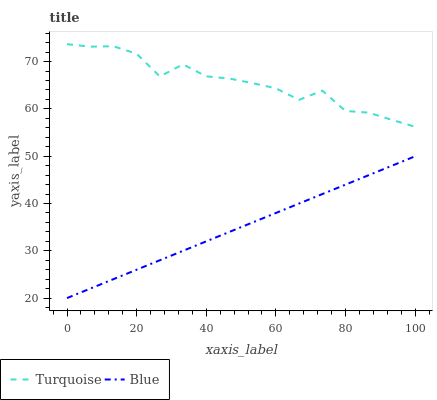Does Blue have the minimum area under the curve?
Answer yes or no. Yes. Does Turquoise have the minimum area under the curve?
Answer yes or no. No. Is Turquoise the roughest?
Answer yes or no. Yes. Is Turquoise the smoothest?
Answer yes or no. No. Does Turquoise have the lowest value?
Answer yes or no. No. Is Blue less than Turquoise?
Answer yes or no. Yes. Is Turquoise greater than Blue?
Answer yes or no. Yes. Does Blue intersect Turquoise?
Answer yes or no. No. 